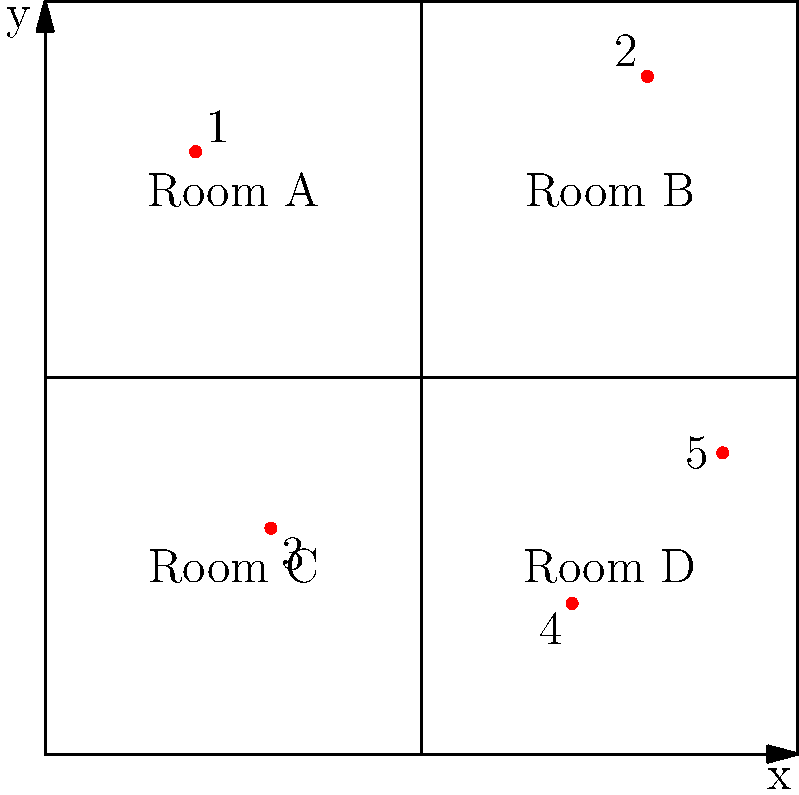The coordinate-based floor plan above represents the distribution of Ludwig I's art collection across four rooms in a museum. Each red dot represents a significant piece from his collection. Based on this layout, which room contains the highest number of art pieces, and what are the coordinates of the artwork in that room? To answer this question, we need to analyze the distribution of the red dots (representing artworks) across the four rooms and identify their coordinates. Let's break it down step-by-step:

1. Identify the rooms:
   - Room A: Top-left quadrant
   - Room B: Top-right quadrant
   - Room C: Bottom-left quadrant
   - Room D: Bottom-right quadrant

2. Count the number of artworks in each room:
   - Room A: 1 artwork
   - Room B: 1 artwork
   - Room C: 1 artwork
   - Room D: 2 artworks

3. Identify the room with the highest number of artworks:
   Room D contains the highest number of artworks (2).

4. Determine the coordinates of the artworks in Room D:
   - Artwork 4: (7, 2)
   - Artwork 5: (9, 4)

Therefore, Room D contains the highest number of art pieces, with coordinates (7, 2) and (9, 4).
Answer: Room D; (7, 2) and (9, 4) 